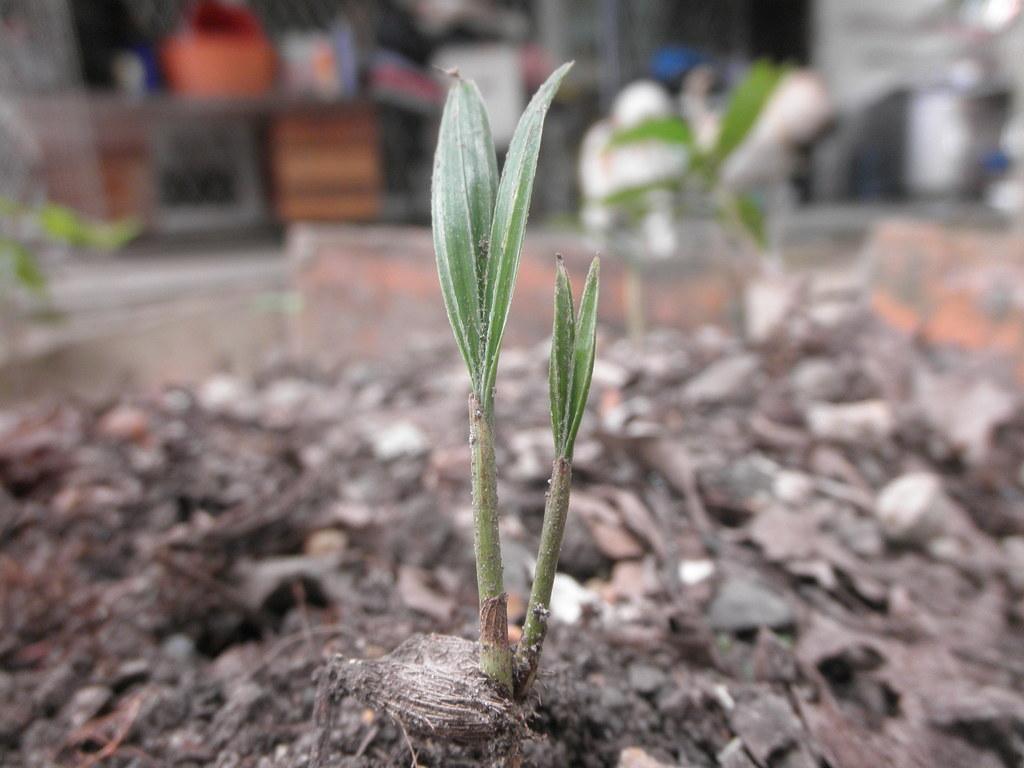Could you give a brief overview of what you see in this image? In this picture we can see a plant. Behind the plant there are some blurred objects. 